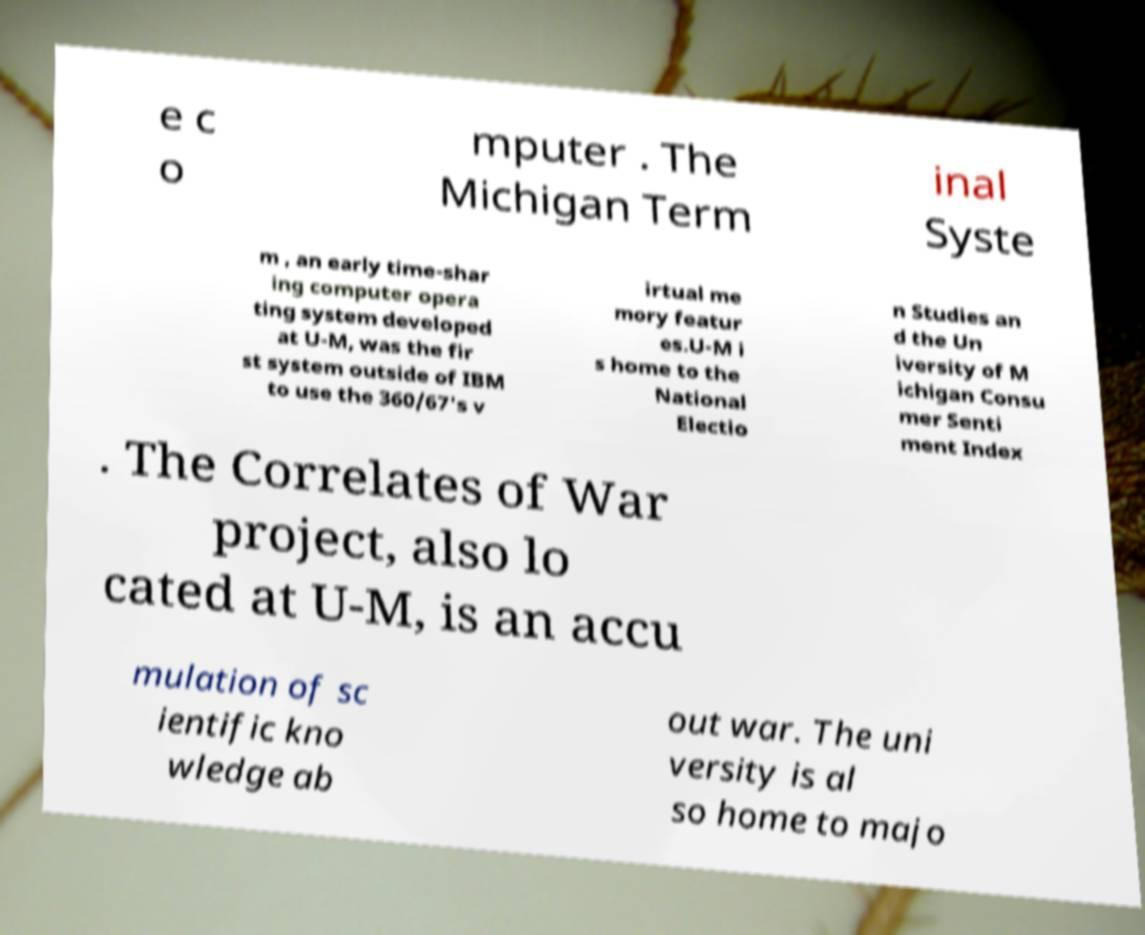What messages or text are displayed in this image? I need them in a readable, typed format. e c o mputer . The Michigan Term inal Syste m , an early time-shar ing computer opera ting system developed at U-M, was the fir st system outside of IBM to use the 360/67's v irtual me mory featur es.U-M i s home to the National Electio n Studies an d the Un iversity of M ichigan Consu mer Senti ment Index . The Correlates of War project, also lo cated at U-M, is an accu mulation of sc ientific kno wledge ab out war. The uni versity is al so home to majo 